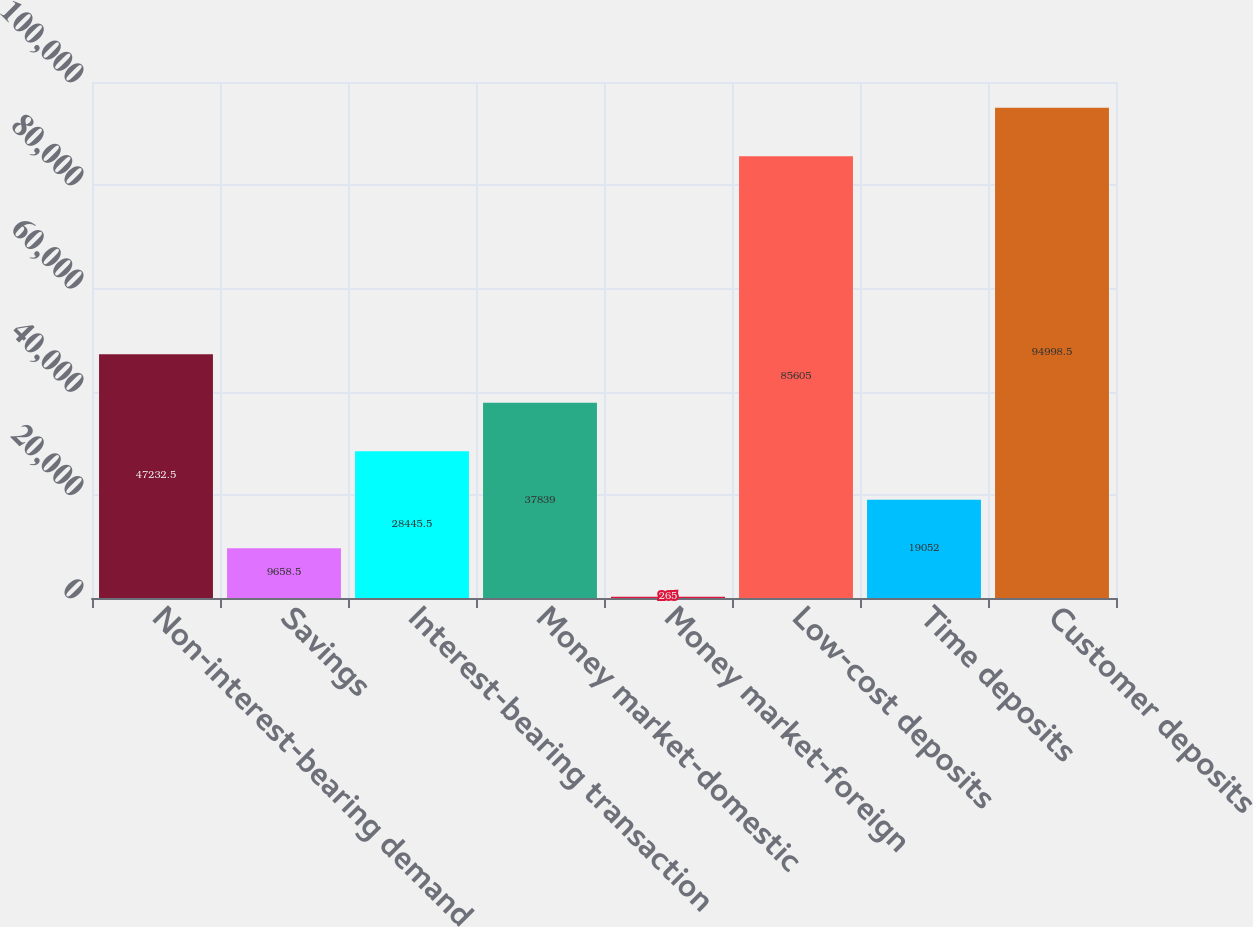<chart> <loc_0><loc_0><loc_500><loc_500><bar_chart><fcel>Non-interest-bearing demand<fcel>Savings<fcel>Interest-bearing transaction<fcel>Money market-domestic<fcel>Money market-foreign<fcel>Low-cost deposits<fcel>Time deposits<fcel>Customer deposits<nl><fcel>47232.5<fcel>9658.5<fcel>28445.5<fcel>37839<fcel>265<fcel>85605<fcel>19052<fcel>94998.5<nl></chart> 